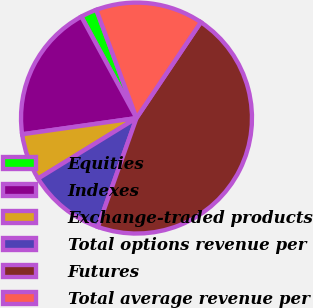Convert chart. <chart><loc_0><loc_0><loc_500><loc_500><pie_chart><fcel>Equities<fcel>Indexes<fcel>Exchange-traded products<fcel>Total options revenue per<fcel>Futures<fcel>Total average revenue per<nl><fcel>2.27%<fcel>19.32%<fcel>6.53%<fcel>10.8%<fcel>46.02%<fcel>15.06%<nl></chart> 